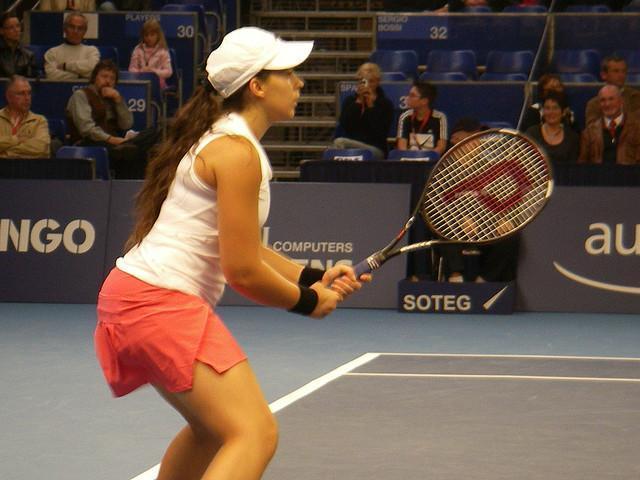How many people can you see?
Give a very brief answer. 8. 